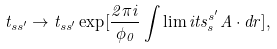<formula> <loc_0><loc_0><loc_500><loc_500>t _ { s s ^ { \prime } } \rightarrow t _ { s s ^ { \prime } } \exp [ \frac { 2 \pi i } { \phi _ { 0 } } \int \lim i t s _ { s } ^ { s ^ { \prime } } { A } \cdot d { r } ] ,</formula> 